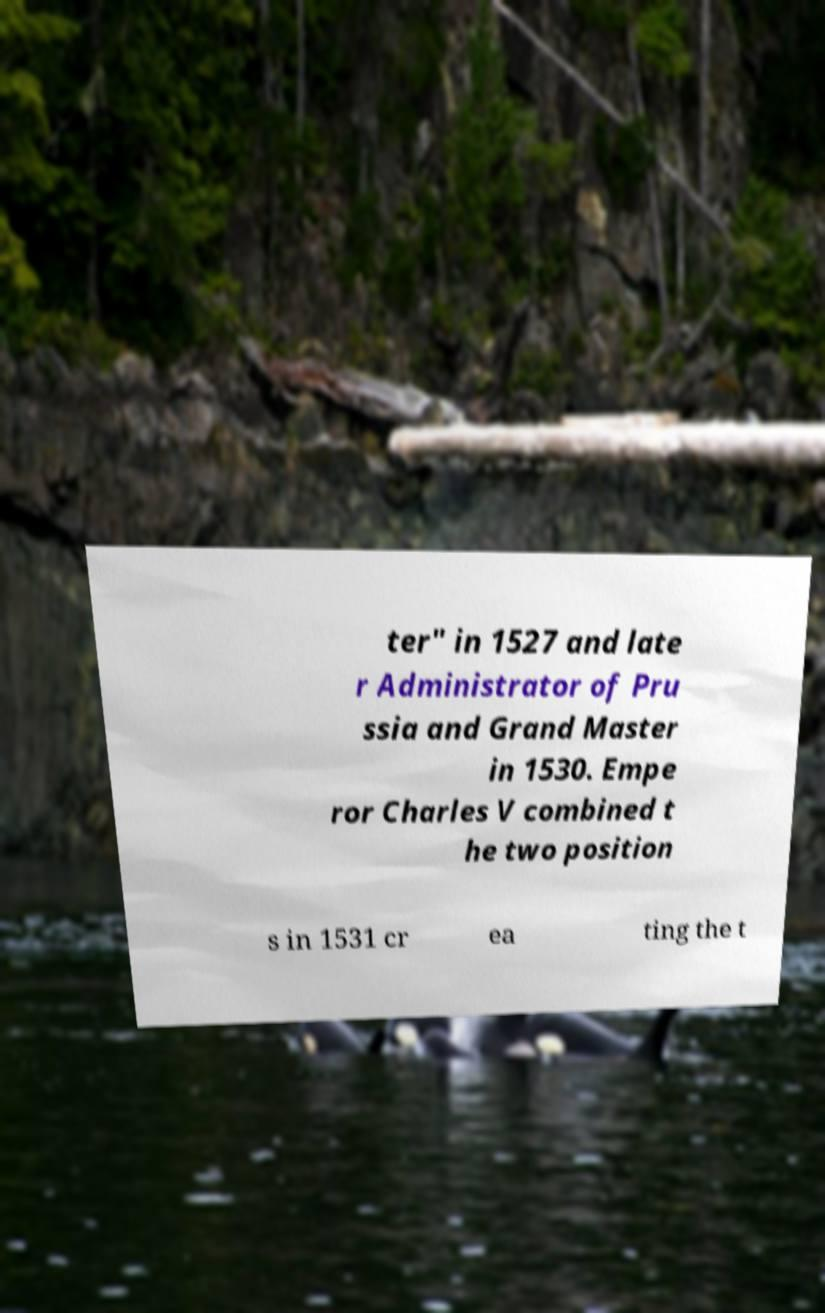There's text embedded in this image that I need extracted. Can you transcribe it verbatim? ter" in 1527 and late r Administrator of Pru ssia and Grand Master in 1530. Empe ror Charles V combined t he two position s in 1531 cr ea ting the t 